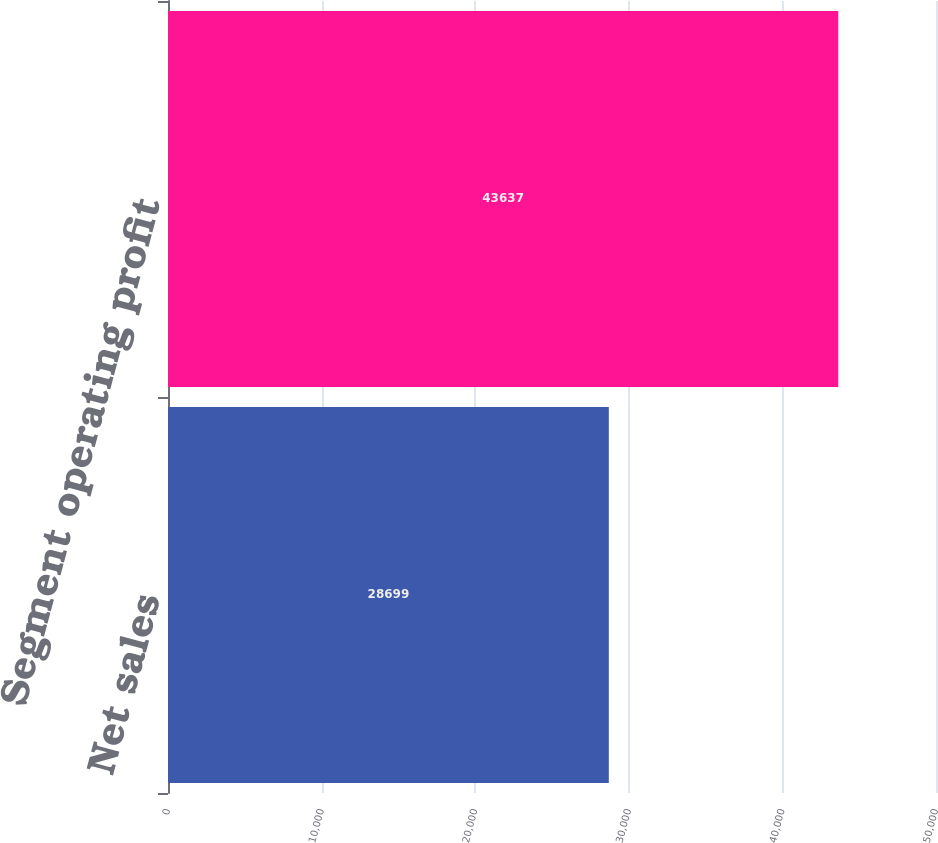Convert chart. <chart><loc_0><loc_0><loc_500><loc_500><bar_chart><fcel>Net sales<fcel>Segment operating profit<nl><fcel>28699<fcel>43637<nl></chart> 